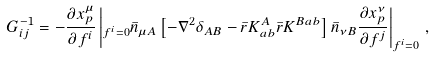<formula> <loc_0><loc_0><loc_500><loc_500>G ^ { - 1 } _ { i j } = - \frac { \partial x _ { p } ^ { \mu } } { \partial f ^ { i } } \left | _ { f ^ { i } = 0 } \bar { n } _ { \mu A } \left [ - \nabla ^ { 2 } \delta _ { A B } - \bar { r } K ^ { A } _ { a b } \bar { r } K ^ { B a b } \right ] \bar { n } _ { \nu B } \frac { \partial x _ { p } ^ { \nu } } { \partial f ^ { j } } \right | _ { f ^ { i } = 0 } \, ,</formula> 